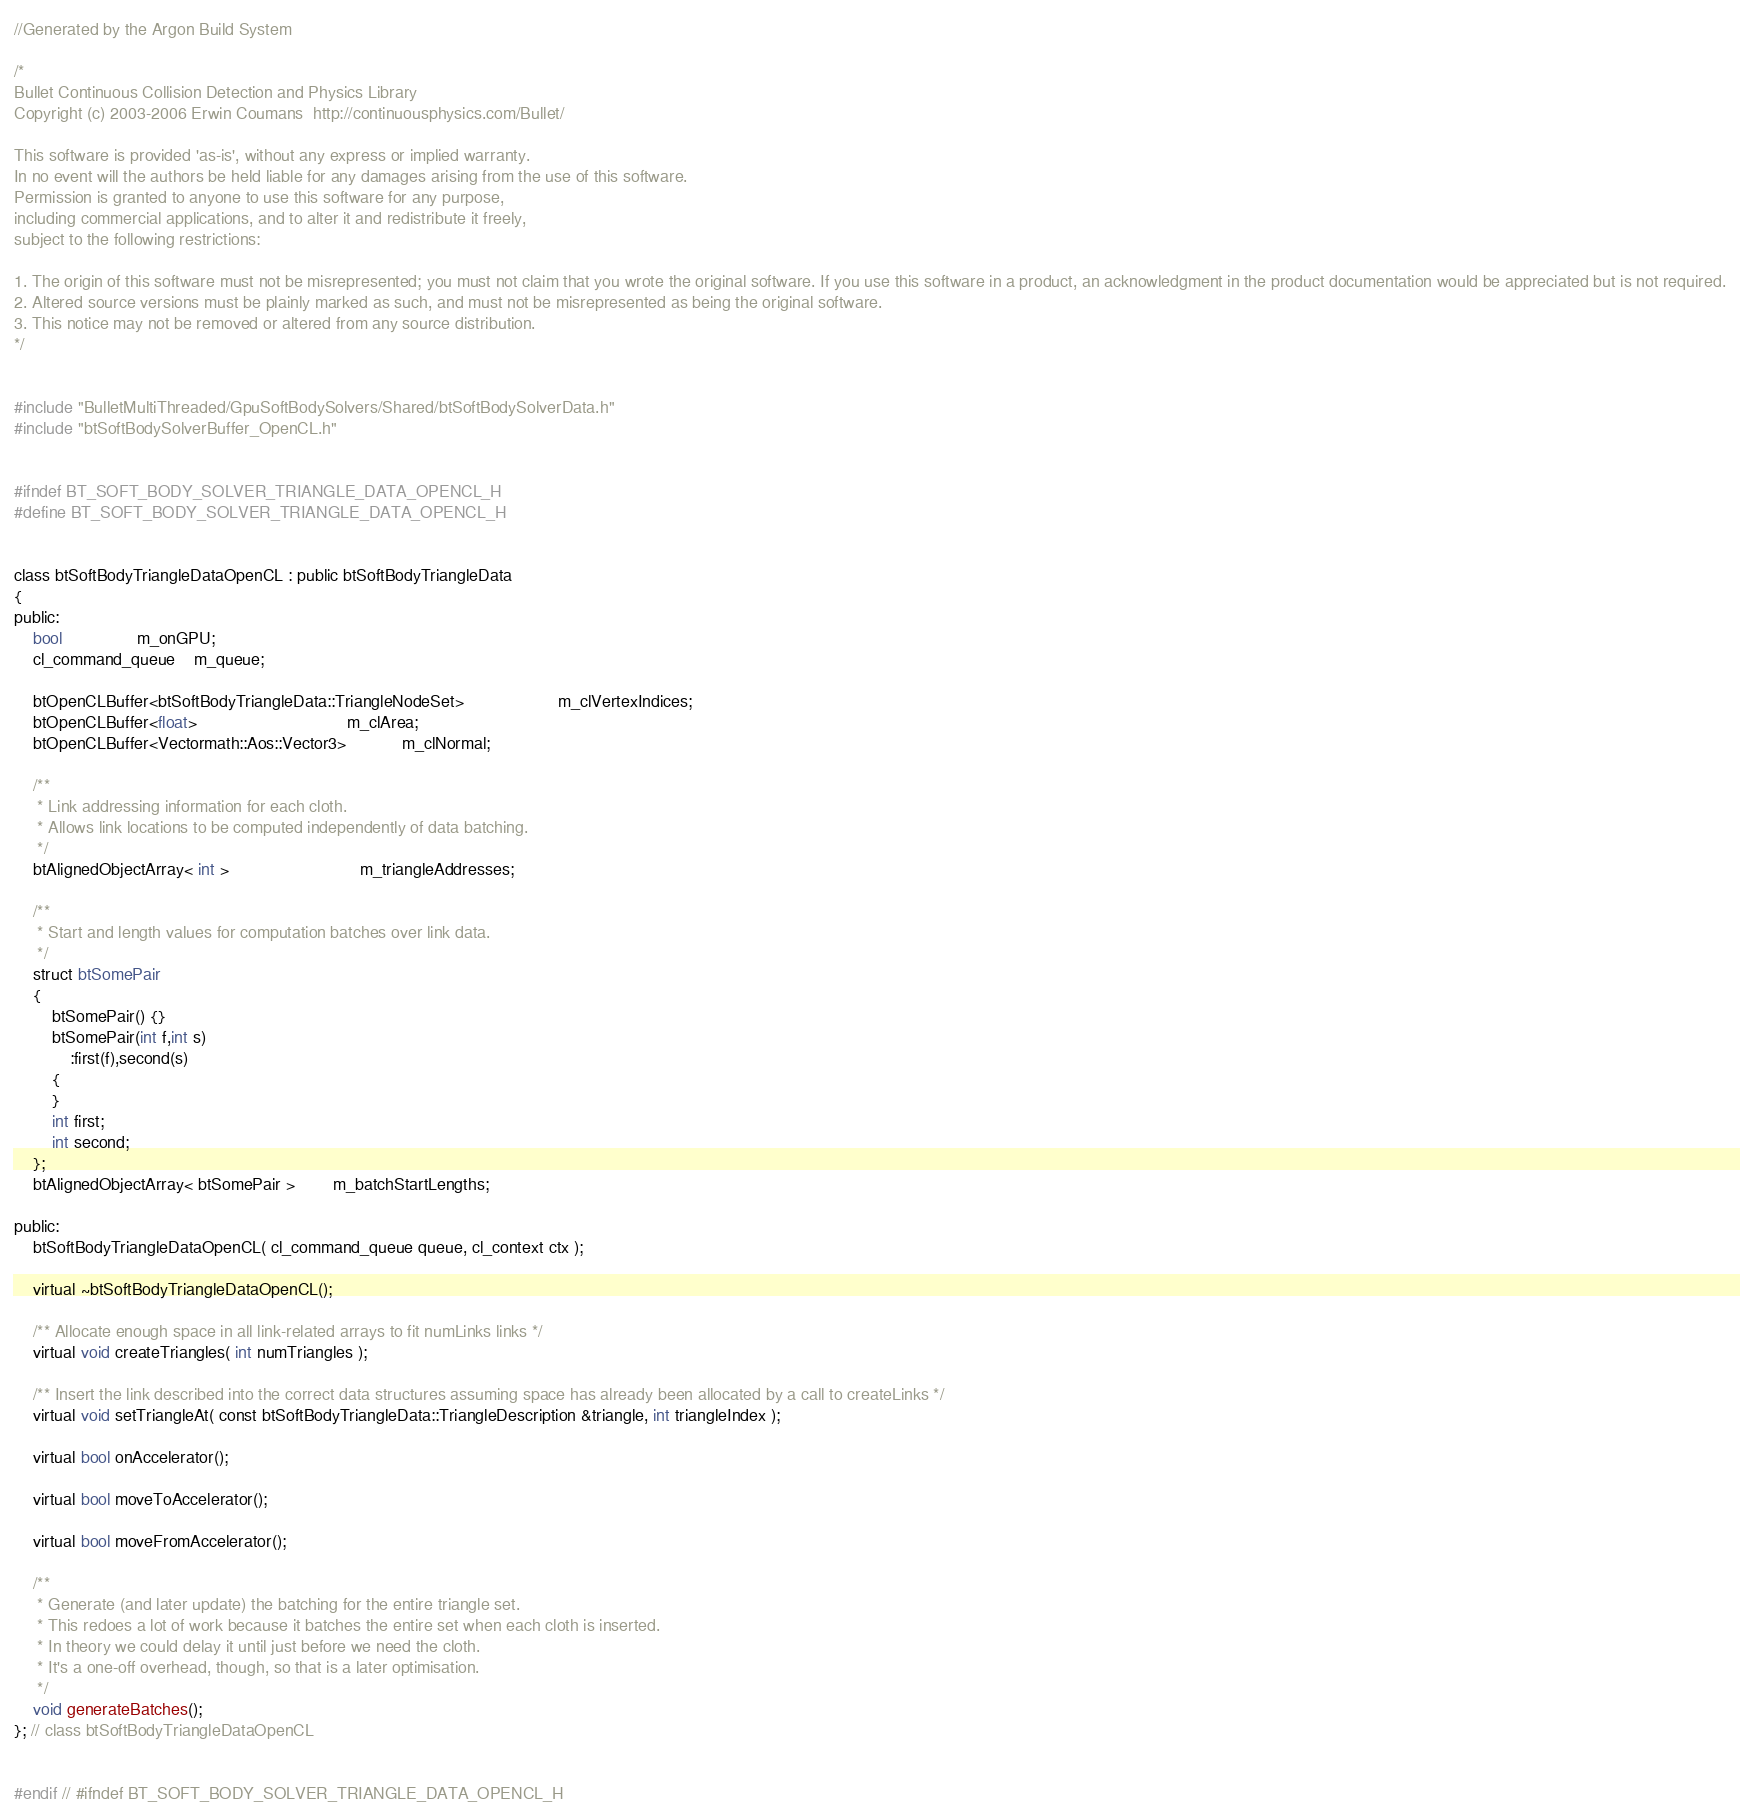Convert code to text. <code><loc_0><loc_0><loc_500><loc_500><_C_>//Generated by the Argon Build System

/*
Bullet Continuous Collision Detection and Physics Library
Copyright (c) 2003-2006 Erwin Coumans  http://continuousphysics.com/Bullet/

This software is provided 'as-is', without any express or implied warranty.
In no event will the authors be held liable for any damages arising from the use of this software.
Permission is granted to anyone to use this software for any purpose, 
including commercial applications, and to alter it and redistribute it freely, 
subject to the following restrictions:

1. The origin of this software must not be misrepresented; you must not claim that you wrote the original software. If you use this software in a product, an acknowledgment in the product documentation would be appreciated but is not required.
2. Altered source versions must be plainly marked as such, and must not be misrepresented as being the original software.
3. This notice may not be removed or altered from any source distribution.
*/


#include "BulletMultiThreaded/GpuSoftBodySolvers/Shared/btSoftBodySolverData.h"
#include "btSoftBodySolverBuffer_OpenCL.h"


#ifndef BT_SOFT_BODY_SOLVER_TRIANGLE_DATA_OPENCL_H
#define BT_SOFT_BODY_SOLVER_TRIANGLE_DATA_OPENCL_H


class btSoftBodyTriangleDataOpenCL : public btSoftBodyTriangleData
{
public:
	bool				m_onGPU;
	cl_command_queue    m_queue;

	btOpenCLBuffer<btSoftBodyTriangleData::TriangleNodeSet>					m_clVertexIndices;
	btOpenCLBuffer<float>								m_clArea;
	btOpenCLBuffer<Vectormath::Aos::Vector3>			m_clNormal;

	/**
	 * Link addressing information for each cloth.
	 * Allows link locations to be computed independently of data batching.
	 */
	btAlignedObjectArray< int >							m_triangleAddresses;

	/**
	 * Start and length values for computation batches over link data.
	 */
	struct btSomePair
	{
		btSomePair() {}
		btSomePair(int f,int s)
			:first(f),second(s)
		{
		}
		int first;
		int second;
	};
	btAlignedObjectArray< btSomePair >		m_batchStartLengths;

public:
	btSoftBodyTriangleDataOpenCL( cl_command_queue queue, cl_context ctx );

	virtual ~btSoftBodyTriangleDataOpenCL();

	/** Allocate enough space in all link-related arrays to fit numLinks links */
	virtual void createTriangles( int numTriangles );
	
	/** Insert the link described into the correct data structures assuming space has already been allocated by a call to createLinks */
	virtual void setTriangleAt( const btSoftBodyTriangleData::TriangleDescription &triangle, int triangleIndex );

	virtual bool onAccelerator();

	virtual bool moveToAccelerator();

	virtual bool moveFromAccelerator();

	/**
	 * Generate (and later update) the batching for the entire triangle set.
	 * This redoes a lot of work because it batches the entire set when each cloth is inserted.
	 * In theory we could delay it until just before we need the cloth.
	 * It's a one-off overhead, though, so that is a later optimisation.
	 */
	void generateBatches();
}; // class btSoftBodyTriangleDataOpenCL


#endif // #ifndef BT_SOFT_BODY_SOLVER_TRIANGLE_DATA_OPENCL_H

</code> 